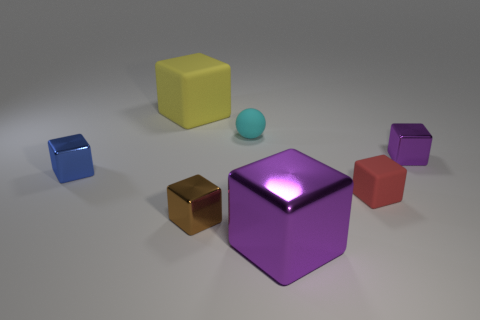Do the large yellow object and the purple shiny object that is in front of the small blue metal cube have the same shape?
Offer a terse response. Yes. What number of big cubes are in front of the small cyan object and behind the cyan rubber thing?
Provide a short and direct response. 0. There is a large purple object that is the same shape as the tiny brown shiny object; what material is it?
Make the answer very short. Metal. What is the size of the purple metallic cube that is to the left of the tiny purple object that is to the right of the large shiny block?
Your answer should be compact. Large. Is there a large blue matte object?
Provide a short and direct response. No. What is the small block that is both on the right side of the small sphere and in front of the blue metallic block made of?
Your response must be concise. Rubber. Are there more blue objects behind the cyan thing than blue shiny cubes in front of the big purple metal object?
Your response must be concise. No. Are there any blue cubes of the same size as the red thing?
Keep it short and to the point. Yes. What is the size of the rubber cube that is on the right side of the yellow block that is behind the tiny metal thing that is behind the blue block?
Offer a terse response. Small. The sphere has what color?
Your response must be concise. Cyan. 